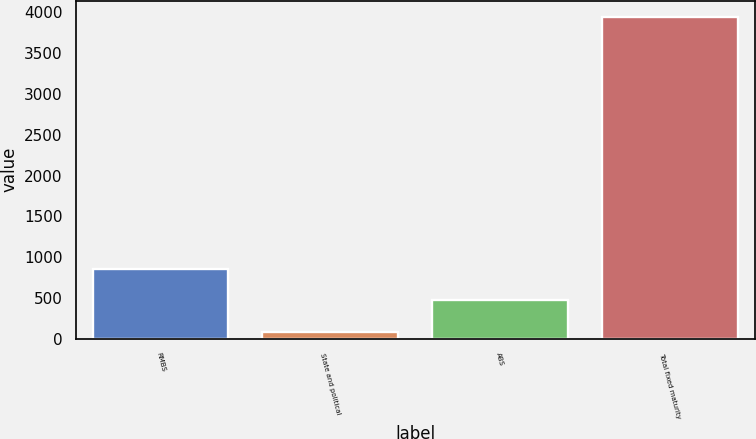<chart> <loc_0><loc_0><loc_500><loc_500><bar_chart><fcel>RMBS<fcel>State and political<fcel>ABS<fcel>Total fixed maturity<nl><fcel>857.2<fcel>85<fcel>471.1<fcel>3946<nl></chart> 